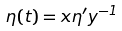<formula> <loc_0><loc_0><loc_500><loc_500>\eta ( t ) = x \eta ^ { \prime } y ^ { - 1 }</formula> 